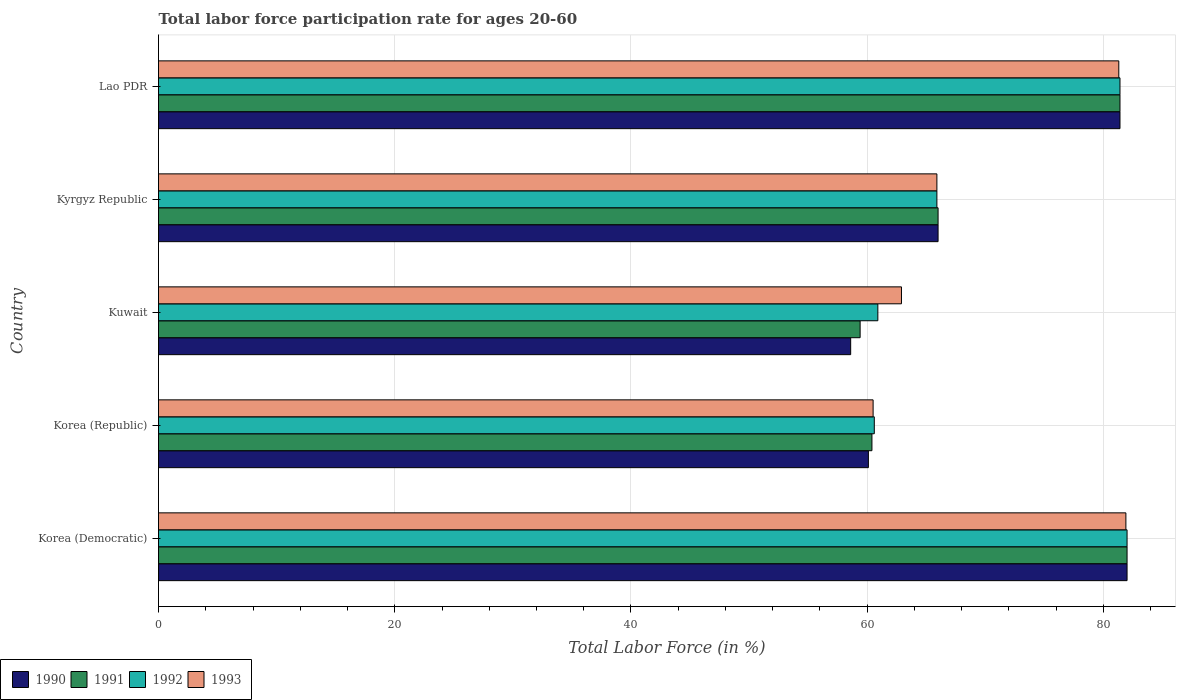Are the number of bars on each tick of the Y-axis equal?
Give a very brief answer. Yes. What is the label of the 3rd group of bars from the top?
Your answer should be very brief. Kuwait. In how many cases, is the number of bars for a given country not equal to the number of legend labels?
Make the answer very short. 0. What is the labor force participation rate in 1990 in Korea (Democratic)?
Provide a succinct answer. 82. Across all countries, what is the minimum labor force participation rate in 1991?
Make the answer very short. 59.4. In which country was the labor force participation rate in 1991 maximum?
Provide a succinct answer. Korea (Democratic). In which country was the labor force participation rate in 1993 minimum?
Make the answer very short. Korea (Republic). What is the total labor force participation rate in 1991 in the graph?
Provide a short and direct response. 349.2. What is the difference between the labor force participation rate in 1992 in Korea (Republic) and that in Kyrgyz Republic?
Your answer should be very brief. -5.3. What is the difference between the labor force participation rate in 1992 in Kyrgyz Republic and the labor force participation rate in 1991 in Korea (Democratic)?
Your answer should be very brief. -16.1. What is the average labor force participation rate in 1990 per country?
Give a very brief answer. 69.62. What is the difference between the labor force participation rate in 1990 and labor force participation rate in 1992 in Kuwait?
Provide a succinct answer. -2.3. What is the ratio of the labor force participation rate in 1990 in Korea (Republic) to that in Kuwait?
Offer a very short reply. 1.03. Is the difference between the labor force participation rate in 1990 in Kyrgyz Republic and Lao PDR greater than the difference between the labor force participation rate in 1992 in Kyrgyz Republic and Lao PDR?
Give a very brief answer. Yes. What is the difference between the highest and the second highest labor force participation rate in 1990?
Your answer should be compact. 0.6. What is the difference between the highest and the lowest labor force participation rate in 1993?
Your answer should be very brief. 21.4. In how many countries, is the labor force participation rate in 1991 greater than the average labor force participation rate in 1991 taken over all countries?
Provide a succinct answer. 2. Is the sum of the labor force participation rate in 1992 in Korea (Democratic) and Korea (Republic) greater than the maximum labor force participation rate in 1993 across all countries?
Ensure brevity in your answer.  Yes. Is it the case that in every country, the sum of the labor force participation rate in 1990 and labor force participation rate in 1992 is greater than the sum of labor force participation rate in 1993 and labor force participation rate in 1991?
Your answer should be very brief. No. What does the 3rd bar from the bottom in Lao PDR represents?
Your answer should be compact. 1992. Is it the case that in every country, the sum of the labor force participation rate in 1993 and labor force participation rate in 1991 is greater than the labor force participation rate in 1990?
Ensure brevity in your answer.  Yes. Are all the bars in the graph horizontal?
Keep it short and to the point. Yes. How many countries are there in the graph?
Offer a terse response. 5. Where does the legend appear in the graph?
Your response must be concise. Bottom left. How many legend labels are there?
Keep it short and to the point. 4. How are the legend labels stacked?
Give a very brief answer. Horizontal. What is the title of the graph?
Ensure brevity in your answer.  Total labor force participation rate for ages 20-60. Does "1970" appear as one of the legend labels in the graph?
Provide a succinct answer. No. What is the label or title of the X-axis?
Your response must be concise. Total Labor Force (in %). What is the label or title of the Y-axis?
Provide a succinct answer. Country. What is the Total Labor Force (in %) in 1990 in Korea (Democratic)?
Ensure brevity in your answer.  82. What is the Total Labor Force (in %) of 1991 in Korea (Democratic)?
Your answer should be compact. 82. What is the Total Labor Force (in %) in 1993 in Korea (Democratic)?
Provide a short and direct response. 81.9. What is the Total Labor Force (in %) in 1990 in Korea (Republic)?
Provide a short and direct response. 60.1. What is the Total Labor Force (in %) of 1991 in Korea (Republic)?
Give a very brief answer. 60.4. What is the Total Labor Force (in %) of 1992 in Korea (Republic)?
Provide a succinct answer. 60.6. What is the Total Labor Force (in %) of 1993 in Korea (Republic)?
Give a very brief answer. 60.5. What is the Total Labor Force (in %) in 1990 in Kuwait?
Make the answer very short. 58.6. What is the Total Labor Force (in %) of 1991 in Kuwait?
Your response must be concise. 59.4. What is the Total Labor Force (in %) in 1992 in Kuwait?
Provide a succinct answer. 60.9. What is the Total Labor Force (in %) of 1993 in Kuwait?
Offer a terse response. 62.9. What is the Total Labor Force (in %) of 1990 in Kyrgyz Republic?
Make the answer very short. 66. What is the Total Labor Force (in %) of 1992 in Kyrgyz Republic?
Make the answer very short. 65.9. What is the Total Labor Force (in %) in 1993 in Kyrgyz Republic?
Give a very brief answer. 65.9. What is the Total Labor Force (in %) of 1990 in Lao PDR?
Your answer should be very brief. 81.4. What is the Total Labor Force (in %) of 1991 in Lao PDR?
Give a very brief answer. 81.4. What is the Total Labor Force (in %) of 1992 in Lao PDR?
Your answer should be compact. 81.4. What is the Total Labor Force (in %) of 1993 in Lao PDR?
Your answer should be very brief. 81.3. Across all countries, what is the maximum Total Labor Force (in %) in 1993?
Keep it short and to the point. 81.9. Across all countries, what is the minimum Total Labor Force (in %) in 1990?
Make the answer very short. 58.6. Across all countries, what is the minimum Total Labor Force (in %) of 1991?
Keep it short and to the point. 59.4. Across all countries, what is the minimum Total Labor Force (in %) in 1992?
Make the answer very short. 60.6. Across all countries, what is the minimum Total Labor Force (in %) of 1993?
Offer a very short reply. 60.5. What is the total Total Labor Force (in %) of 1990 in the graph?
Your response must be concise. 348.1. What is the total Total Labor Force (in %) in 1991 in the graph?
Your response must be concise. 349.2. What is the total Total Labor Force (in %) of 1992 in the graph?
Give a very brief answer. 350.8. What is the total Total Labor Force (in %) in 1993 in the graph?
Provide a succinct answer. 352.5. What is the difference between the Total Labor Force (in %) of 1990 in Korea (Democratic) and that in Korea (Republic)?
Your answer should be very brief. 21.9. What is the difference between the Total Labor Force (in %) of 1991 in Korea (Democratic) and that in Korea (Republic)?
Provide a succinct answer. 21.6. What is the difference between the Total Labor Force (in %) in 1992 in Korea (Democratic) and that in Korea (Republic)?
Your answer should be compact. 21.4. What is the difference between the Total Labor Force (in %) in 1993 in Korea (Democratic) and that in Korea (Republic)?
Offer a very short reply. 21.4. What is the difference between the Total Labor Force (in %) in 1990 in Korea (Democratic) and that in Kuwait?
Keep it short and to the point. 23.4. What is the difference between the Total Labor Force (in %) of 1991 in Korea (Democratic) and that in Kuwait?
Ensure brevity in your answer.  22.6. What is the difference between the Total Labor Force (in %) of 1992 in Korea (Democratic) and that in Kuwait?
Give a very brief answer. 21.1. What is the difference between the Total Labor Force (in %) in 1993 in Korea (Democratic) and that in Kyrgyz Republic?
Offer a very short reply. 16. What is the difference between the Total Labor Force (in %) in 1992 in Korea (Democratic) and that in Lao PDR?
Make the answer very short. 0.6. What is the difference between the Total Labor Force (in %) in 1991 in Korea (Republic) and that in Kuwait?
Offer a very short reply. 1. What is the difference between the Total Labor Force (in %) in 1992 in Korea (Republic) and that in Kuwait?
Provide a succinct answer. -0.3. What is the difference between the Total Labor Force (in %) of 1993 in Korea (Republic) and that in Kuwait?
Your answer should be compact. -2.4. What is the difference between the Total Labor Force (in %) of 1991 in Korea (Republic) and that in Kyrgyz Republic?
Keep it short and to the point. -5.6. What is the difference between the Total Labor Force (in %) in 1992 in Korea (Republic) and that in Kyrgyz Republic?
Provide a short and direct response. -5.3. What is the difference between the Total Labor Force (in %) of 1990 in Korea (Republic) and that in Lao PDR?
Provide a succinct answer. -21.3. What is the difference between the Total Labor Force (in %) in 1992 in Korea (Republic) and that in Lao PDR?
Your answer should be compact. -20.8. What is the difference between the Total Labor Force (in %) in 1993 in Korea (Republic) and that in Lao PDR?
Ensure brevity in your answer.  -20.8. What is the difference between the Total Labor Force (in %) of 1990 in Kuwait and that in Kyrgyz Republic?
Your answer should be very brief. -7.4. What is the difference between the Total Labor Force (in %) of 1991 in Kuwait and that in Kyrgyz Republic?
Your answer should be compact. -6.6. What is the difference between the Total Labor Force (in %) in 1992 in Kuwait and that in Kyrgyz Republic?
Provide a succinct answer. -5. What is the difference between the Total Labor Force (in %) in 1993 in Kuwait and that in Kyrgyz Republic?
Offer a terse response. -3. What is the difference between the Total Labor Force (in %) of 1990 in Kuwait and that in Lao PDR?
Ensure brevity in your answer.  -22.8. What is the difference between the Total Labor Force (in %) in 1991 in Kuwait and that in Lao PDR?
Your answer should be very brief. -22. What is the difference between the Total Labor Force (in %) of 1992 in Kuwait and that in Lao PDR?
Your response must be concise. -20.5. What is the difference between the Total Labor Force (in %) of 1993 in Kuwait and that in Lao PDR?
Give a very brief answer. -18.4. What is the difference between the Total Labor Force (in %) in 1990 in Kyrgyz Republic and that in Lao PDR?
Your answer should be compact. -15.4. What is the difference between the Total Labor Force (in %) in 1991 in Kyrgyz Republic and that in Lao PDR?
Provide a short and direct response. -15.4. What is the difference between the Total Labor Force (in %) in 1992 in Kyrgyz Republic and that in Lao PDR?
Offer a terse response. -15.5. What is the difference between the Total Labor Force (in %) of 1993 in Kyrgyz Republic and that in Lao PDR?
Your answer should be compact. -15.4. What is the difference between the Total Labor Force (in %) of 1990 in Korea (Democratic) and the Total Labor Force (in %) of 1991 in Korea (Republic)?
Give a very brief answer. 21.6. What is the difference between the Total Labor Force (in %) of 1990 in Korea (Democratic) and the Total Labor Force (in %) of 1992 in Korea (Republic)?
Keep it short and to the point. 21.4. What is the difference between the Total Labor Force (in %) in 1991 in Korea (Democratic) and the Total Labor Force (in %) in 1992 in Korea (Republic)?
Give a very brief answer. 21.4. What is the difference between the Total Labor Force (in %) of 1990 in Korea (Democratic) and the Total Labor Force (in %) of 1991 in Kuwait?
Keep it short and to the point. 22.6. What is the difference between the Total Labor Force (in %) in 1990 in Korea (Democratic) and the Total Labor Force (in %) in 1992 in Kuwait?
Your response must be concise. 21.1. What is the difference between the Total Labor Force (in %) of 1991 in Korea (Democratic) and the Total Labor Force (in %) of 1992 in Kuwait?
Ensure brevity in your answer.  21.1. What is the difference between the Total Labor Force (in %) of 1991 in Korea (Democratic) and the Total Labor Force (in %) of 1993 in Kuwait?
Keep it short and to the point. 19.1. What is the difference between the Total Labor Force (in %) in 1992 in Korea (Democratic) and the Total Labor Force (in %) in 1993 in Kuwait?
Your response must be concise. 19.1. What is the difference between the Total Labor Force (in %) of 1990 in Korea (Democratic) and the Total Labor Force (in %) of 1993 in Kyrgyz Republic?
Ensure brevity in your answer.  16.1. What is the difference between the Total Labor Force (in %) of 1991 in Korea (Democratic) and the Total Labor Force (in %) of 1992 in Kyrgyz Republic?
Offer a very short reply. 16.1. What is the difference between the Total Labor Force (in %) in 1991 in Korea (Democratic) and the Total Labor Force (in %) in 1993 in Kyrgyz Republic?
Your answer should be very brief. 16.1. What is the difference between the Total Labor Force (in %) in 1992 in Korea (Democratic) and the Total Labor Force (in %) in 1993 in Kyrgyz Republic?
Offer a very short reply. 16.1. What is the difference between the Total Labor Force (in %) in 1990 in Korea (Democratic) and the Total Labor Force (in %) in 1993 in Lao PDR?
Your answer should be compact. 0.7. What is the difference between the Total Labor Force (in %) of 1991 in Korea (Democratic) and the Total Labor Force (in %) of 1993 in Lao PDR?
Keep it short and to the point. 0.7. What is the difference between the Total Labor Force (in %) in 1990 in Korea (Republic) and the Total Labor Force (in %) in 1993 in Kuwait?
Keep it short and to the point. -2.8. What is the difference between the Total Labor Force (in %) of 1991 in Korea (Republic) and the Total Labor Force (in %) of 1993 in Kuwait?
Your response must be concise. -2.5. What is the difference between the Total Labor Force (in %) of 1992 in Korea (Republic) and the Total Labor Force (in %) of 1993 in Kuwait?
Make the answer very short. -2.3. What is the difference between the Total Labor Force (in %) of 1990 in Korea (Republic) and the Total Labor Force (in %) of 1993 in Kyrgyz Republic?
Offer a terse response. -5.8. What is the difference between the Total Labor Force (in %) of 1991 in Korea (Republic) and the Total Labor Force (in %) of 1992 in Kyrgyz Republic?
Your response must be concise. -5.5. What is the difference between the Total Labor Force (in %) in 1991 in Korea (Republic) and the Total Labor Force (in %) in 1993 in Kyrgyz Republic?
Offer a terse response. -5.5. What is the difference between the Total Labor Force (in %) of 1992 in Korea (Republic) and the Total Labor Force (in %) of 1993 in Kyrgyz Republic?
Provide a short and direct response. -5.3. What is the difference between the Total Labor Force (in %) of 1990 in Korea (Republic) and the Total Labor Force (in %) of 1991 in Lao PDR?
Your response must be concise. -21.3. What is the difference between the Total Labor Force (in %) in 1990 in Korea (Republic) and the Total Labor Force (in %) in 1992 in Lao PDR?
Provide a succinct answer. -21.3. What is the difference between the Total Labor Force (in %) of 1990 in Korea (Republic) and the Total Labor Force (in %) of 1993 in Lao PDR?
Make the answer very short. -21.2. What is the difference between the Total Labor Force (in %) of 1991 in Korea (Republic) and the Total Labor Force (in %) of 1993 in Lao PDR?
Your answer should be compact. -20.9. What is the difference between the Total Labor Force (in %) in 1992 in Korea (Republic) and the Total Labor Force (in %) in 1993 in Lao PDR?
Make the answer very short. -20.7. What is the difference between the Total Labor Force (in %) in 1990 in Kuwait and the Total Labor Force (in %) in 1991 in Kyrgyz Republic?
Your answer should be compact. -7.4. What is the difference between the Total Labor Force (in %) of 1990 in Kuwait and the Total Labor Force (in %) of 1993 in Kyrgyz Republic?
Give a very brief answer. -7.3. What is the difference between the Total Labor Force (in %) of 1991 in Kuwait and the Total Labor Force (in %) of 1992 in Kyrgyz Republic?
Offer a very short reply. -6.5. What is the difference between the Total Labor Force (in %) of 1990 in Kuwait and the Total Labor Force (in %) of 1991 in Lao PDR?
Offer a very short reply. -22.8. What is the difference between the Total Labor Force (in %) of 1990 in Kuwait and the Total Labor Force (in %) of 1992 in Lao PDR?
Provide a succinct answer. -22.8. What is the difference between the Total Labor Force (in %) in 1990 in Kuwait and the Total Labor Force (in %) in 1993 in Lao PDR?
Your answer should be compact. -22.7. What is the difference between the Total Labor Force (in %) of 1991 in Kuwait and the Total Labor Force (in %) of 1992 in Lao PDR?
Make the answer very short. -22. What is the difference between the Total Labor Force (in %) in 1991 in Kuwait and the Total Labor Force (in %) in 1993 in Lao PDR?
Keep it short and to the point. -21.9. What is the difference between the Total Labor Force (in %) of 1992 in Kuwait and the Total Labor Force (in %) of 1993 in Lao PDR?
Your answer should be compact. -20.4. What is the difference between the Total Labor Force (in %) in 1990 in Kyrgyz Republic and the Total Labor Force (in %) in 1991 in Lao PDR?
Your response must be concise. -15.4. What is the difference between the Total Labor Force (in %) in 1990 in Kyrgyz Republic and the Total Labor Force (in %) in 1992 in Lao PDR?
Keep it short and to the point. -15.4. What is the difference between the Total Labor Force (in %) in 1990 in Kyrgyz Republic and the Total Labor Force (in %) in 1993 in Lao PDR?
Make the answer very short. -15.3. What is the difference between the Total Labor Force (in %) of 1991 in Kyrgyz Republic and the Total Labor Force (in %) of 1992 in Lao PDR?
Keep it short and to the point. -15.4. What is the difference between the Total Labor Force (in %) in 1991 in Kyrgyz Republic and the Total Labor Force (in %) in 1993 in Lao PDR?
Provide a succinct answer. -15.3. What is the difference between the Total Labor Force (in %) of 1992 in Kyrgyz Republic and the Total Labor Force (in %) of 1993 in Lao PDR?
Provide a succinct answer. -15.4. What is the average Total Labor Force (in %) of 1990 per country?
Offer a very short reply. 69.62. What is the average Total Labor Force (in %) of 1991 per country?
Make the answer very short. 69.84. What is the average Total Labor Force (in %) of 1992 per country?
Your answer should be very brief. 70.16. What is the average Total Labor Force (in %) in 1993 per country?
Offer a very short reply. 70.5. What is the difference between the Total Labor Force (in %) of 1990 and Total Labor Force (in %) of 1991 in Korea (Democratic)?
Your response must be concise. 0. What is the difference between the Total Labor Force (in %) of 1990 and Total Labor Force (in %) of 1992 in Korea (Democratic)?
Your response must be concise. 0. What is the difference between the Total Labor Force (in %) in 1990 and Total Labor Force (in %) in 1993 in Korea (Democratic)?
Your answer should be very brief. 0.1. What is the difference between the Total Labor Force (in %) of 1991 and Total Labor Force (in %) of 1992 in Korea (Democratic)?
Provide a short and direct response. 0. What is the difference between the Total Labor Force (in %) of 1992 and Total Labor Force (in %) of 1993 in Korea (Republic)?
Offer a very short reply. 0.1. What is the difference between the Total Labor Force (in %) of 1990 and Total Labor Force (in %) of 1991 in Kuwait?
Make the answer very short. -0.8. What is the difference between the Total Labor Force (in %) of 1990 and Total Labor Force (in %) of 1992 in Kuwait?
Offer a terse response. -2.3. What is the difference between the Total Labor Force (in %) in 1990 and Total Labor Force (in %) in 1991 in Kyrgyz Republic?
Offer a terse response. 0. What is the difference between the Total Labor Force (in %) in 1991 and Total Labor Force (in %) in 1992 in Kyrgyz Republic?
Ensure brevity in your answer.  0.1. What is the difference between the Total Labor Force (in %) in 1990 and Total Labor Force (in %) in 1993 in Lao PDR?
Offer a very short reply. 0.1. What is the difference between the Total Labor Force (in %) of 1992 and Total Labor Force (in %) of 1993 in Lao PDR?
Ensure brevity in your answer.  0.1. What is the ratio of the Total Labor Force (in %) in 1990 in Korea (Democratic) to that in Korea (Republic)?
Give a very brief answer. 1.36. What is the ratio of the Total Labor Force (in %) in 1991 in Korea (Democratic) to that in Korea (Republic)?
Ensure brevity in your answer.  1.36. What is the ratio of the Total Labor Force (in %) in 1992 in Korea (Democratic) to that in Korea (Republic)?
Provide a short and direct response. 1.35. What is the ratio of the Total Labor Force (in %) of 1993 in Korea (Democratic) to that in Korea (Republic)?
Give a very brief answer. 1.35. What is the ratio of the Total Labor Force (in %) in 1990 in Korea (Democratic) to that in Kuwait?
Ensure brevity in your answer.  1.4. What is the ratio of the Total Labor Force (in %) of 1991 in Korea (Democratic) to that in Kuwait?
Make the answer very short. 1.38. What is the ratio of the Total Labor Force (in %) of 1992 in Korea (Democratic) to that in Kuwait?
Keep it short and to the point. 1.35. What is the ratio of the Total Labor Force (in %) of 1993 in Korea (Democratic) to that in Kuwait?
Your response must be concise. 1.3. What is the ratio of the Total Labor Force (in %) of 1990 in Korea (Democratic) to that in Kyrgyz Republic?
Offer a terse response. 1.24. What is the ratio of the Total Labor Force (in %) in 1991 in Korea (Democratic) to that in Kyrgyz Republic?
Provide a short and direct response. 1.24. What is the ratio of the Total Labor Force (in %) of 1992 in Korea (Democratic) to that in Kyrgyz Republic?
Give a very brief answer. 1.24. What is the ratio of the Total Labor Force (in %) of 1993 in Korea (Democratic) to that in Kyrgyz Republic?
Provide a succinct answer. 1.24. What is the ratio of the Total Labor Force (in %) of 1990 in Korea (Democratic) to that in Lao PDR?
Offer a terse response. 1.01. What is the ratio of the Total Labor Force (in %) in 1991 in Korea (Democratic) to that in Lao PDR?
Keep it short and to the point. 1.01. What is the ratio of the Total Labor Force (in %) in 1992 in Korea (Democratic) to that in Lao PDR?
Offer a very short reply. 1.01. What is the ratio of the Total Labor Force (in %) in 1993 in Korea (Democratic) to that in Lao PDR?
Ensure brevity in your answer.  1.01. What is the ratio of the Total Labor Force (in %) in 1990 in Korea (Republic) to that in Kuwait?
Provide a succinct answer. 1.03. What is the ratio of the Total Labor Force (in %) of 1991 in Korea (Republic) to that in Kuwait?
Give a very brief answer. 1.02. What is the ratio of the Total Labor Force (in %) in 1993 in Korea (Republic) to that in Kuwait?
Provide a short and direct response. 0.96. What is the ratio of the Total Labor Force (in %) of 1990 in Korea (Republic) to that in Kyrgyz Republic?
Keep it short and to the point. 0.91. What is the ratio of the Total Labor Force (in %) in 1991 in Korea (Republic) to that in Kyrgyz Republic?
Keep it short and to the point. 0.92. What is the ratio of the Total Labor Force (in %) of 1992 in Korea (Republic) to that in Kyrgyz Republic?
Offer a very short reply. 0.92. What is the ratio of the Total Labor Force (in %) of 1993 in Korea (Republic) to that in Kyrgyz Republic?
Provide a short and direct response. 0.92. What is the ratio of the Total Labor Force (in %) in 1990 in Korea (Republic) to that in Lao PDR?
Make the answer very short. 0.74. What is the ratio of the Total Labor Force (in %) of 1991 in Korea (Republic) to that in Lao PDR?
Make the answer very short. 0.74. What is the ratio of the Total Labor Force (in %) of 1992 in Korea (Republic) to that in Lao PDR?
Your answer should be compact. 0.74. What is the ratio of the Total Labor Force (in %) of 1993 in Korea (Republic) to that in Lao PDR?
Ensure brevity in your answer.  0.74. What is the ratio of the Total Labor Force (in %) in 1990 in Kuwait to that in Kyrgyz Republic?
Keep it short and to the point. 0.89. What is the ratio of the Total Labor Force (in %) in 1992 in Kuwait to that in Kyrgyz Republic?
Provide a succinct answer. 0.92. What is the ratio of the Total Labor Force (in %) of 1993 in Kuwait to that in Kyrgyz Republic?
Offer a very short reply. 0.95. What is the ratio of the Total Labor Force (in %) in 1990 in Kuwait to that in Lao PDR?
Offer a very short reply. 0.72. What is the ratio of the Total Labor Force (in %) of 1991 in Kuwait to that in Lao PDR?
Your response must be concise. 0.73. What is the ratio of the Total Labor Force (in %) of 1992 in Kuwait to that in Lao PDR?
Provide a succinct answer. 0.75. What is the ratio of the Total Labor Force (in %) of 1993 in Kuwait to that in Lao PDR?
Offer a very short reply. 0.77. What is the ratio of the Total Labor Force (in %) of 1990 in Kyrgyz Republic to that in Lao PDR?
Offer a very short reply. 0.81. What is the ratio of the Total Labor Force (in %) of 1991 in Kyrgyz Republic to that in Lao PDR?
Give a very brief answer. 0.81. What is the ratio of the Total Labor Force (in %) of 1992 in Kyrgyz Republic to that in Lao PDR?
Offer a very short reply. 0.81. What is the ratio of the Total Labor Force (in %) of 1993 in Kyrgyz Republic to that in Lao PDR?
Your response must be concise. 0.81. What is the difference between the highest and the lowest Total Labor Force (in %) in 1990?
Make the answer very short. 23.4. What is the difference between the highest and the lowest Total Labor Force (in %) in 1991?
Offer a very short reply. 22.6. What is the difference between the highest and the lowest Total Labor Force (in %) in 1992?
Your answer should be very brief. 21.4. What is the difference between the highest and the lowest Total Labor Force (in %) in 1993?
Give a very brief answer. 21.4. 